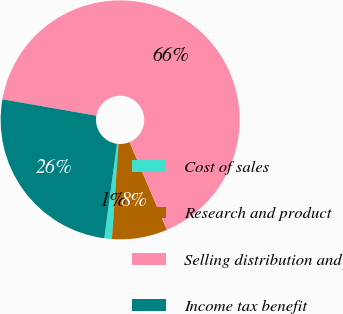Convert chart to OTSL. <chart><loc_0><loc_0><loc_500><loc_500><pie_chart><fcel>Cost of sales<fcel>Research and product<fcel>Selling distribution and<fcel>Income tax benefit<nl><fcel>1.02%<fcel>7.5%<fcel>65.83%<fcel>25.64%<nl></chart> 